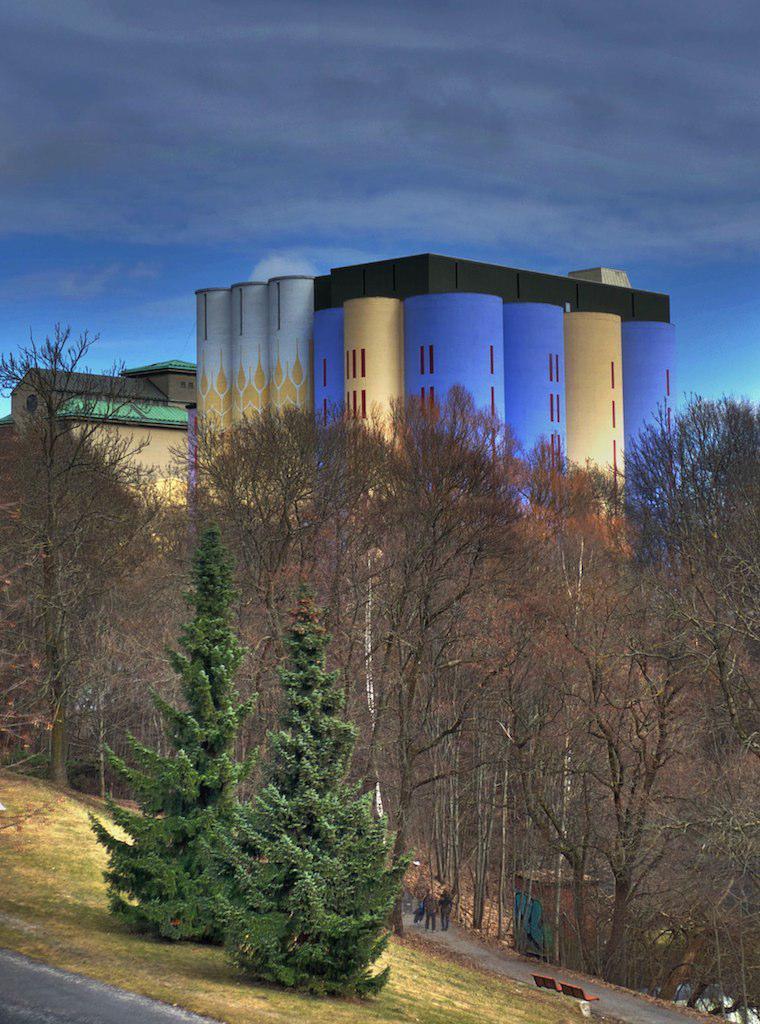Can you describe this image briefly? In this image in the foreground there are two plants, road, on which persons and bench, trees, buildings visible, at the top there is the sky. 